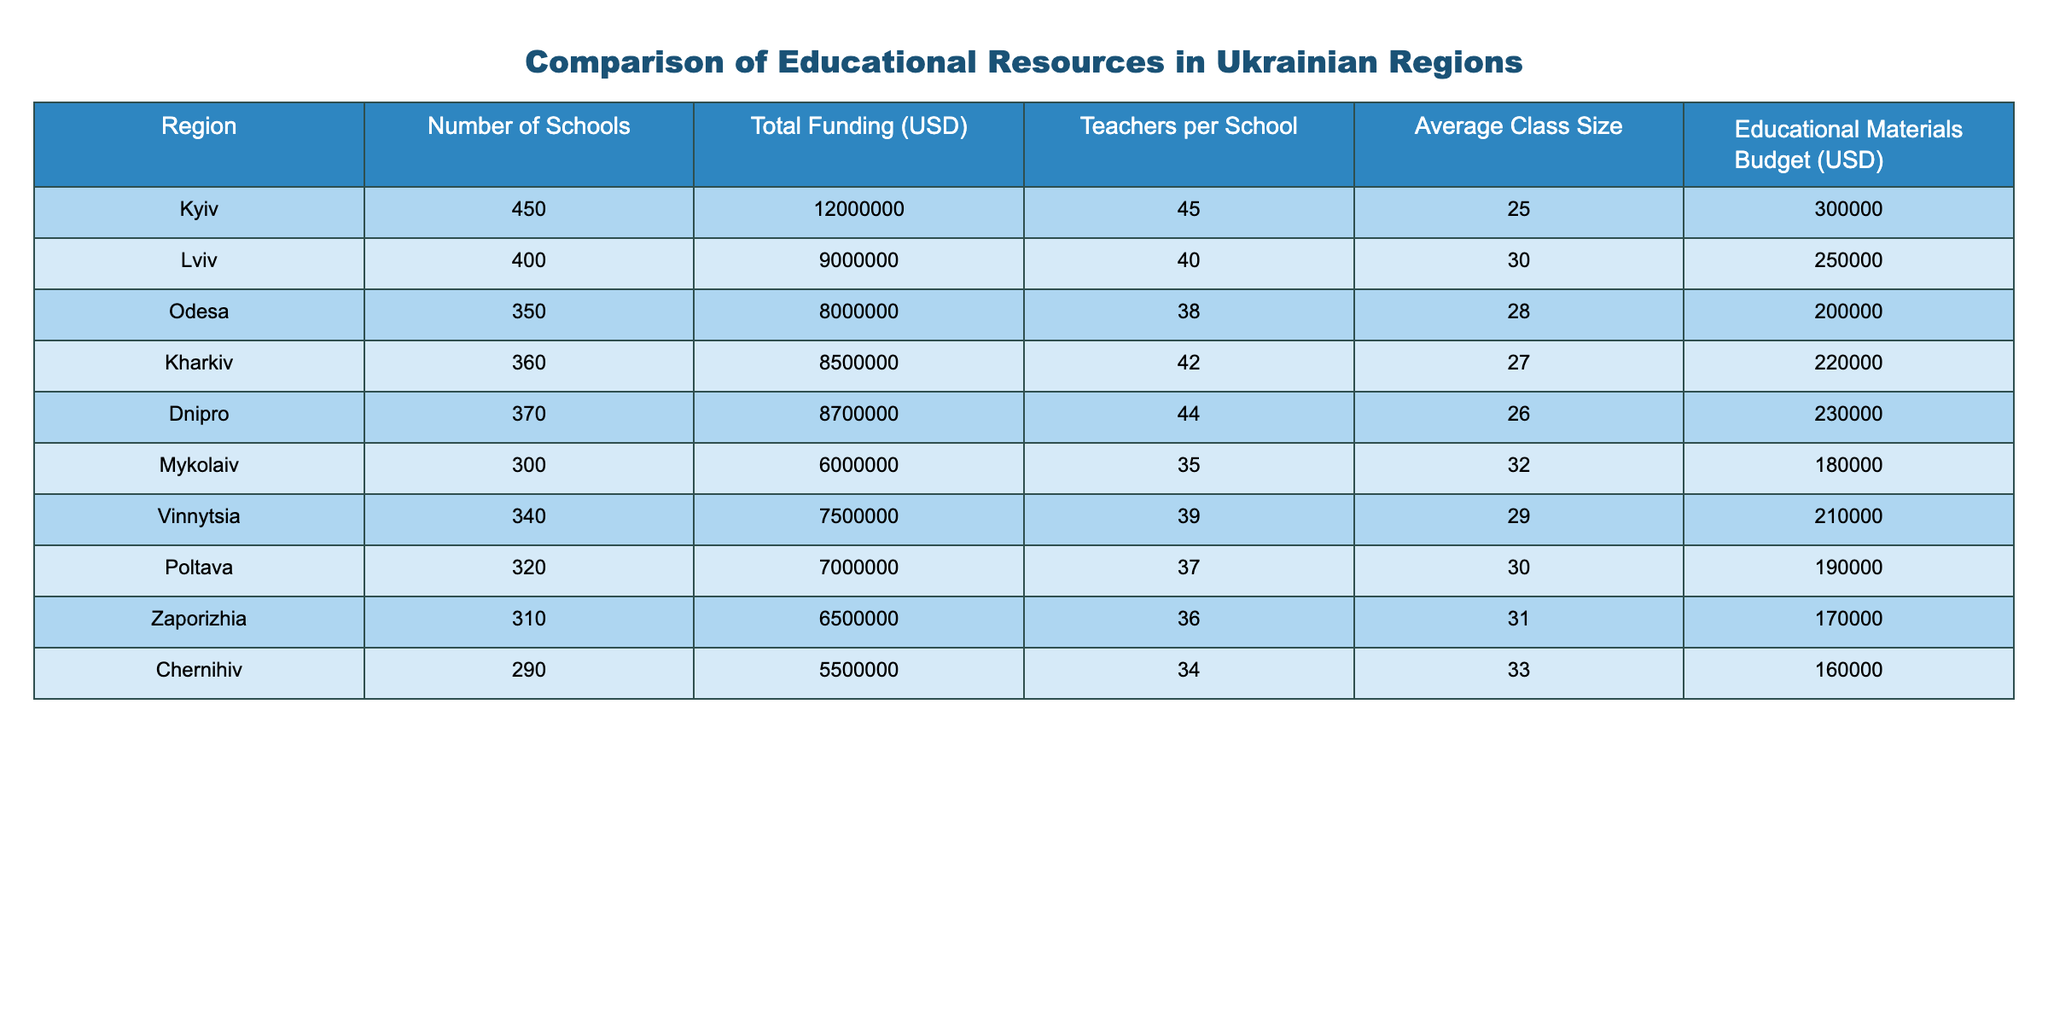What is the total funding allocated to educational resources in Kyiv? According to the table, the total funding for Kyiv is listed directly under the "Total Funding (USD)" column, which shows a value of 12,000,000.
Answer: 12,000,000 Which region has the highest number of teachers per school? Looking at the "Teachers per School" column, Kyiv has 45 teachers per school, which is higher than any other region listed.
Answer: Kyiv What is the average class size across all regions in the table? To find the average class size, we add all the class sizes (25 + 30 + 28 + 27 + 26 + 32 + 29 + 30 + 31 + 33 =  296) and divide by the number of regions (10), yielding an average class size of 29.6.
Answer: 29.6 Does Odesa have a larger educational materials budget than Mykolaiv? The table shows Odesa's educational materials budget is 200,000 and Mykolaiv's is 180,000, confirming that Odesa does have a larger budget.
Answer: Yes Which region has the lowest total funding? By examining the "Total Funding (USD)" column, it is evident that Chernihiv has the lowest allocation at 5,500,000, making it the region with the least funding.
Answer: Chernihiv What is the difference in the number of schools between Lviv and Zaporizhia? The number of schools in Lviv is 400, and in Zaporizhia, it is 310. The difference can be calculated as 400 - 310 = 90 schools.
Answer: 90 If you sum the educational materials budgets of Vinnytsia and Poltava, what is the result? Vinnytsia's budget is 210,000, and Poltava's is 190,000. Adding these two amounts gives 210,000 + 190,000 = 400,000 for their combined educational materials budgets.
Answer: 400,000 Among the regions listed, does Dnipro have a smaller average class size than Kharkiv? Dnipro's average class size is 26, while Kharkiv's average class size is 27. Therefore, Dnipro does have a smaller class size when compared to Kharkiv.
Answer: Yes What percentage of the total funding does Kyiv represent in the overall state education funding, assuming the total funding for all regions is equal to 70,000,000? First, calculate the percentage using the formula (Kyiv's funding / Total funding) * 100 = (12,000,000 / 70,000,000) * 100 = approximately 17.14%.
Answer: 17.14% 